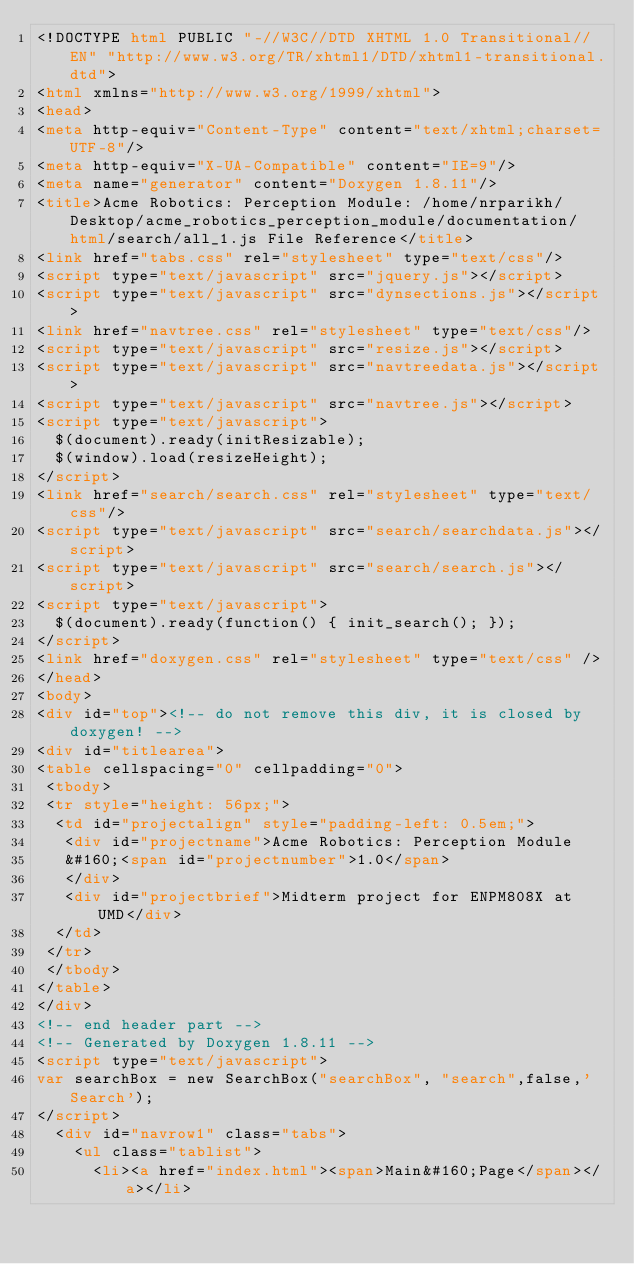<code> <loc_0><loc_0><loc_500><loc_500><_HTML_><!DOCTYPE html PUBLIC "-//W3C//DTD XHTML 1.0 Transitional//EN" "http://www.w3.org/TR/xhtml1/DTD/xhtml1-transitional.dtd">
<html xmlns="http://www.w3.org/1999/xhtml">
<head>
<meta http-equiv="Content-Type" content="text/xhtml;charset=UTF-8"/>
<meta http-equiv="X-UA-Compatible" content="IE=9"/>
<meta name="generator" content="Doxygen 1.8.11"/>
<title>Acme Robotics: Perception Module: /home/nrparikh/Desktop/acme_robotics_perception_module/documentation/html/search/all_1.js File Reference</title>
<link href="tabs.css" rel="stylesheet" type="text/css"/>
<script type="text/javascript" src="jquery.js"></script>
<script type="text/javascript" src="dynsections.js"></script>
<link href="navtree.css" rel="stylesheet" type="text/css"/>
<script type="text/javascript" src="resize.js"></script>
<script type="text/javascript" src="navtreedata.js"></script>
<script type="text/javascript" src="navtree.js"></script>
<script type="text/javascript">
  $(document).ready(initResizable);
  $(window).load(resizeHeight);
</script>
<link href="search/search.css" rel="stylesheet" type="text/css"/>
<script type="text/javascript" src="search/searchdata.js"></script>
<script type="text/javascript" src="search/search.js"></script>
<script type="text/javascript">
  $(document).ready(function() { init_search(); });
</script>
<link href="doxygen.css" rel="stylesheet" type="text/css" />
</head>
<body>
<div id="top"><!-- do not remove this div, it is closed by doxygen! -->
<div id="titlearea">
<table cellspacing="0" cellpadding="0">
 <tbody>
 <tr style="height: 56px;">
  <td id="projectalign" style="padding-left: 0.5em;">
   <div id="projectname">Acme Robotics: Perception Module
   &#160;<span id="projectnumber">1.0</span>
   </div>
   <div id="projectbrief">Midterm project for ENPM808X at UMD</div>
  </td>
 </tr>
 </tbody>
</table>
</div>
<!-- end header part -->
<!-- Generated by Doxygen 1.8.11 -->
<script type="text/javascript">
var searchBox = new SearchBox("searchBox", "search",false,'Search');
</script>
  <div id="navrow1" class="tabs">
    <ul class="tablist">
      <li><a href="index.html"><span>Main&#160;Page</span></a></li></code> 